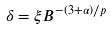Convert formula to latex. <formula><loc_0><loc_0><loc_500><loc_500>\delta = \xi B ^ { - ( 3 + \alpha ) / p }</formula> 